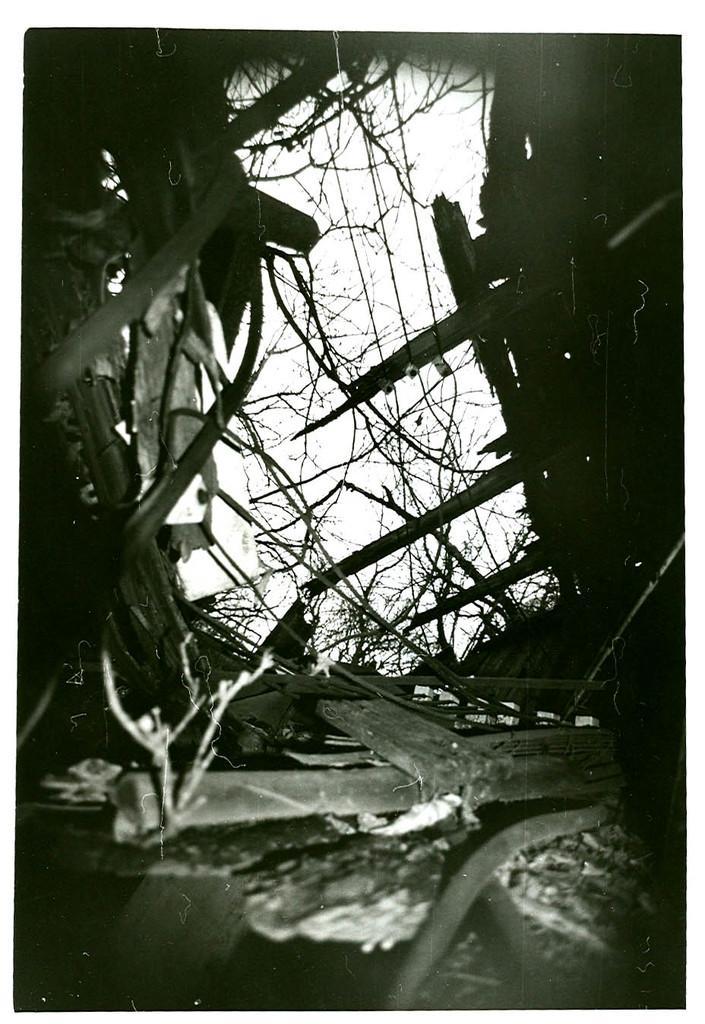In one or two sentences, can you explain what this image depicts? It is the black and white image in which we can see there are wooden sticks on the ground. At the bottom there is a pipe. There wooden sticks on either side of the image. 